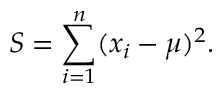Convert formula to latex. <formula><loc_0><loc_0><loc_500><loc_500>S = \sum _ { i = 1 } ^ { n } ( x _ { i } - \mu ) ^ { 2 } .</formula> 